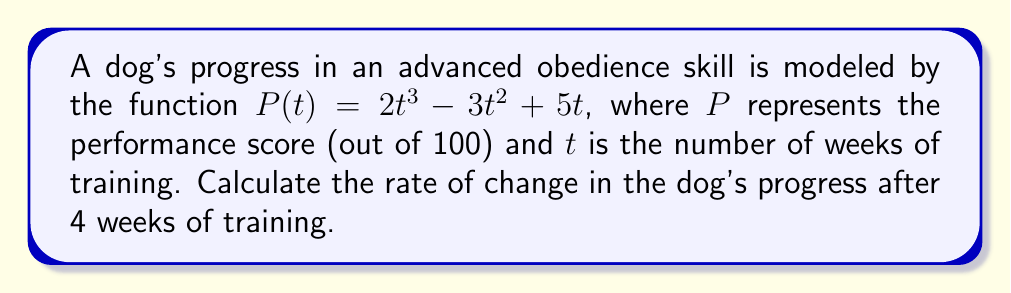Can you solve this math problem? To find the rate of change in the dog's progress, we need to calculate the derivative of the function $P(t)$ and then evaluate it at $t = 4$.

Step 1: Calculate the derivative of $P(t)$.
$$\begin{align}
P(t) &= 2t^3 - 3t^2 + 5t \\
P'(t) &= \frac{d}{dt}(2t^3 - 3t^2 + 5t) \\
&= 6t^2 - 6t + 5
\end{align}$$

Step 2: Evaluate $P'(t)$ at $t = 4$.
$$\begin{align}
P'(4) &= 6(4)^2 - 6(4) + 5 \\
&= 6(16) - 24 + 5 \\
&= 96 - 24 + 5 \\
&= 77
\end{align}$$

The rate of change in the dog's progress after 4 weeks of training is 77 points per week.
Answer: 77 points/week 